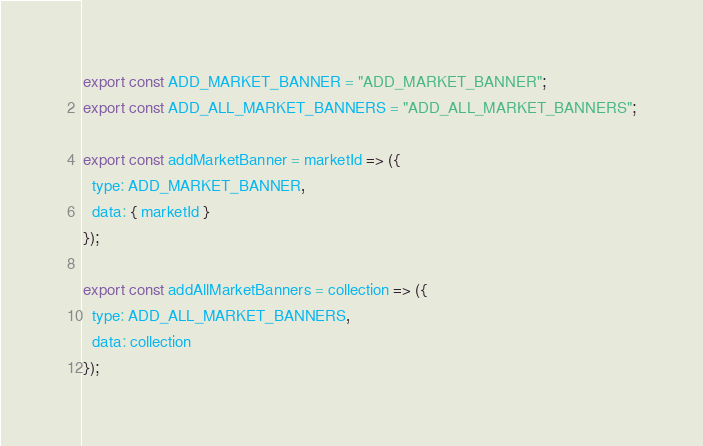Convert code to text. <code><loc_0><loc_0><loc_500><loc_500><_JavaScript_>export const ADD_MARKET_BANNER = "ADD_MARKET_BANNER";
export const ADD_ALL_MARKET_BANNERS = "ADD_ALL_MARKET_BANNERS";

export const addMarketBanner = marketId => ({
  type: ADD_MARKET_BANNER,
  data: { marketId }
});

export const addAllMarketBanners = collection => ({
  type: ADD_ALL_MARKET_BANNERS,
  data: collection
});
</code> 